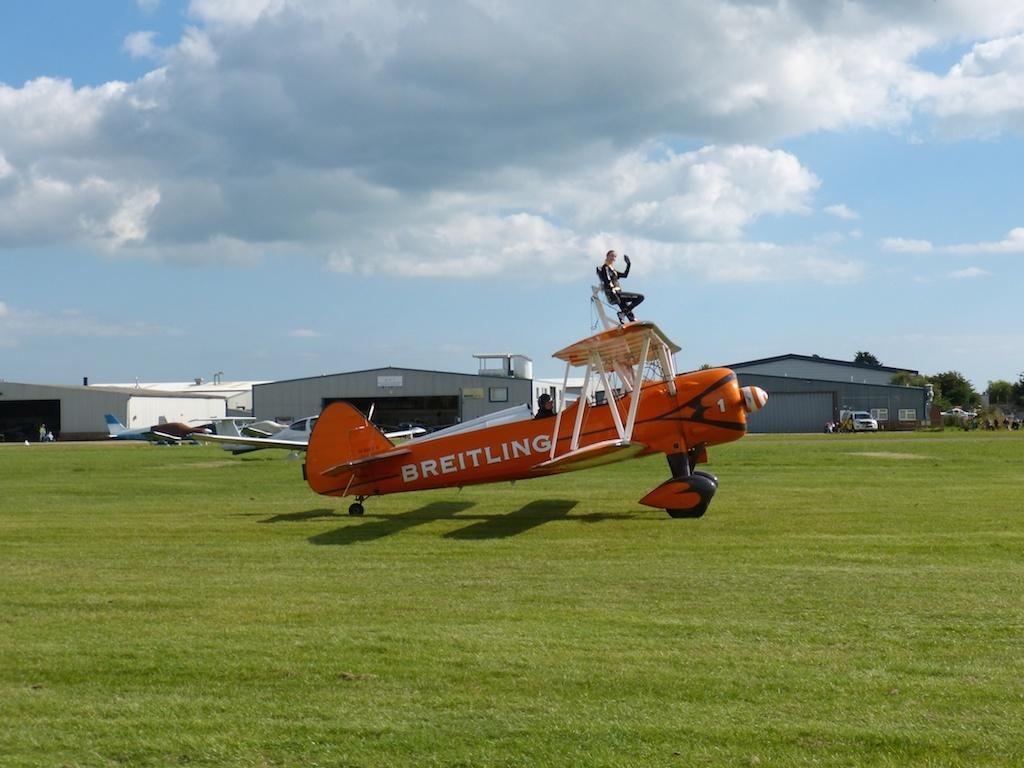<image>
Summarize the visual content of the image. the word Breitling is on the side of a plane 